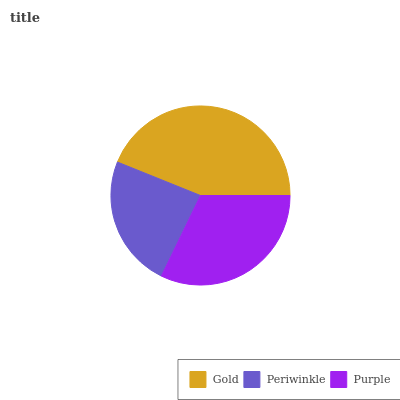Is Periwinkle the minimum?
Answer yes or no. Yes. Is Gold the maximum?
Answer yes or no. Yes. Is Purple the minimum?
Answer yes or no. No. Is Purple the maximum?
Answer yes or no. No. Is Purple greater than Periwinkle?
Answer yes or no. Yes. Is Periwinkle less than Purple?
Answer yes or no. Yes. Is Periwinkle greater than Purple?
Answer yes or no. No. Is Purple less than Periwinkle?
Answer yes or no. No. Is Purple the high median?
Answer yes or no. Yes. Is Purple the low median?
Answer yes or no. Yes. Is Gold the high median?
Answer yes or no. No. Is Gold the low median?
Answer yes or no. No. 